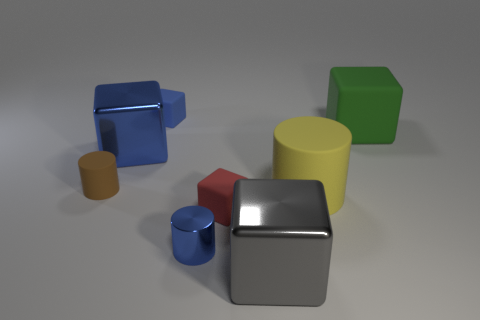Do the big gray metal object and the tiny matte object behind the tiny brown matte cylinder have the same shape?
Provide a succinct answer. Yes. Are any big blue spheres visible?
Your response must be concise. No. What number of large things are cyan cylinders or red matte blocks?
Offer a terse response. 0. Are there more green blocks that are on the left side of the yellow thing than tiny red cubes that are behind the small red cube?
Offer a terse response. No. Does the blue cylinder have the same material as the tiny cube to the left of the small red rubber block?
Make the answer very short. No. What is the color of the small metallic cylinder?
Offer a terse response. Blue. What shape is the tiny blue thing that is in front of the big yellow cylinder?
Your answer should be compact. Cylinder. How many yellow objects are either shiny cubes or metallic cylinders?
Offer a very short reply. 0. What is the color of the other big cylinder that is made of the same material as the brown cylinder?
Keep it short and to the point. Yellow. Does the big cylinder have the same color as the big block that is left of the gray metal cube?
Ensure brevity in your answer.  No. 